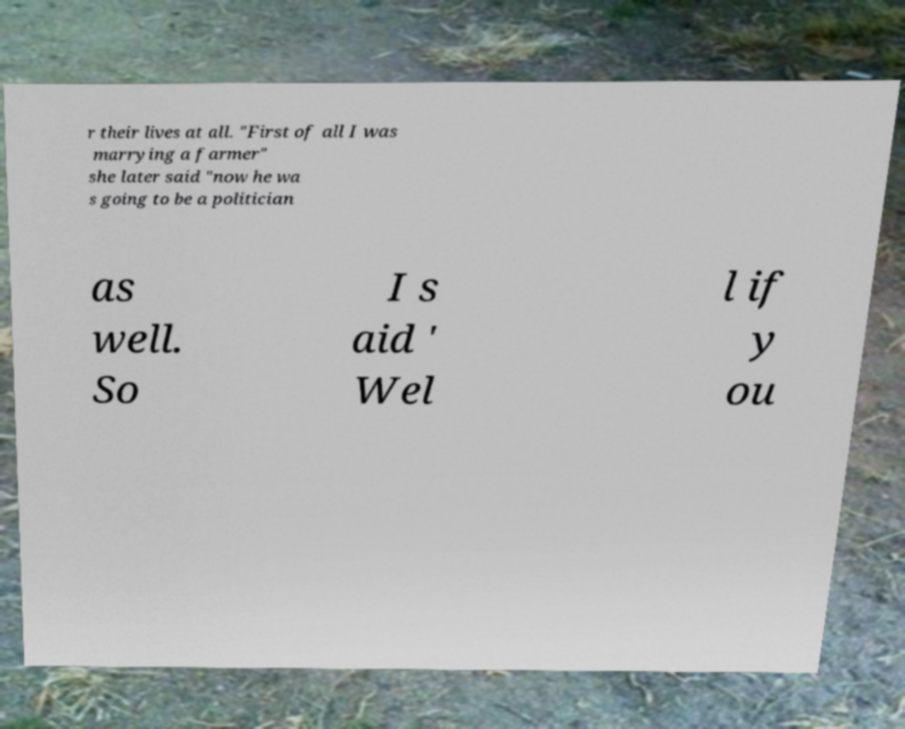Can you read and provide the text displayed in the image?This photo seems to have some interesting text. Can you extract and type it out for me? r their lives at all. "First of all I was marrying a farmer" she later said "now he wa s going to be a politician as well. So I s aid ' Wel l if y ou 